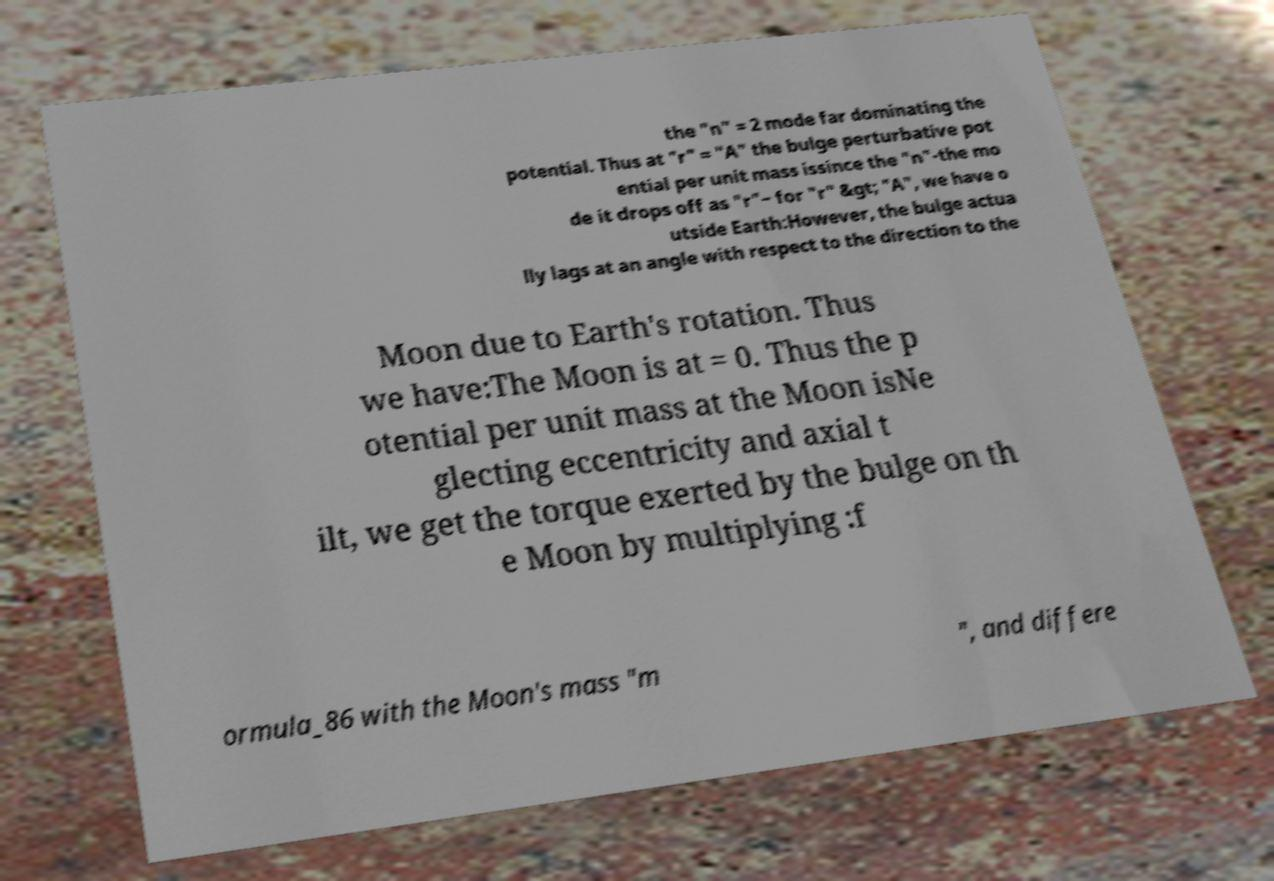Can you accurately transcribe the text from the provided image for me? the "n" = 2 mode far dominating the potential. Thus at "r" = "A" the bulge perturbative pot ential per unit mass issince the "n"-the mo de it drops off as "r"− for "r" &gt; "A", we have o utside Earth:However, the bulge actua lly lags at an angle with respect to the direction to the Moon due to Earth's rotation. Thus we have:The Moon is at = 0. Thus the p otential per unit mass at the Moon isNe glecting eccentricity and axial t ilt, we get the torque exerted by the bulge on th e Moon by multiplying :f ormula_86 with the Moon's mass "m ", and differe 